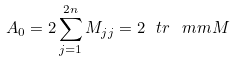<formula> <loc_0><loc_0><loc_500><loc_500>A _ { 0 } = 2 \sum _ { j = 1 } ^ { 2 n } M _ { j j } = 2 \ t r \ m m { M }</formula> 